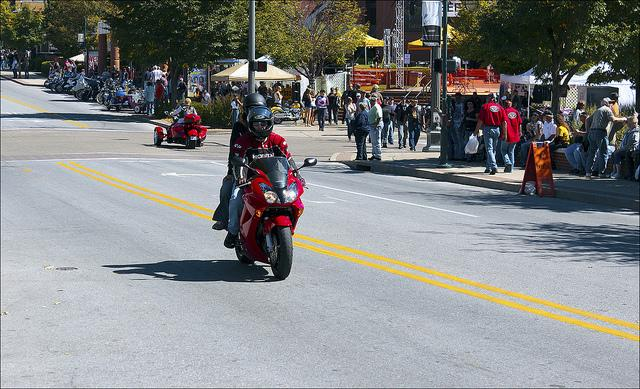What type of vehicles are most shown here?

Choices:
A) bicycles
B) trains
C) cars
D) motorcycles motorcycles 